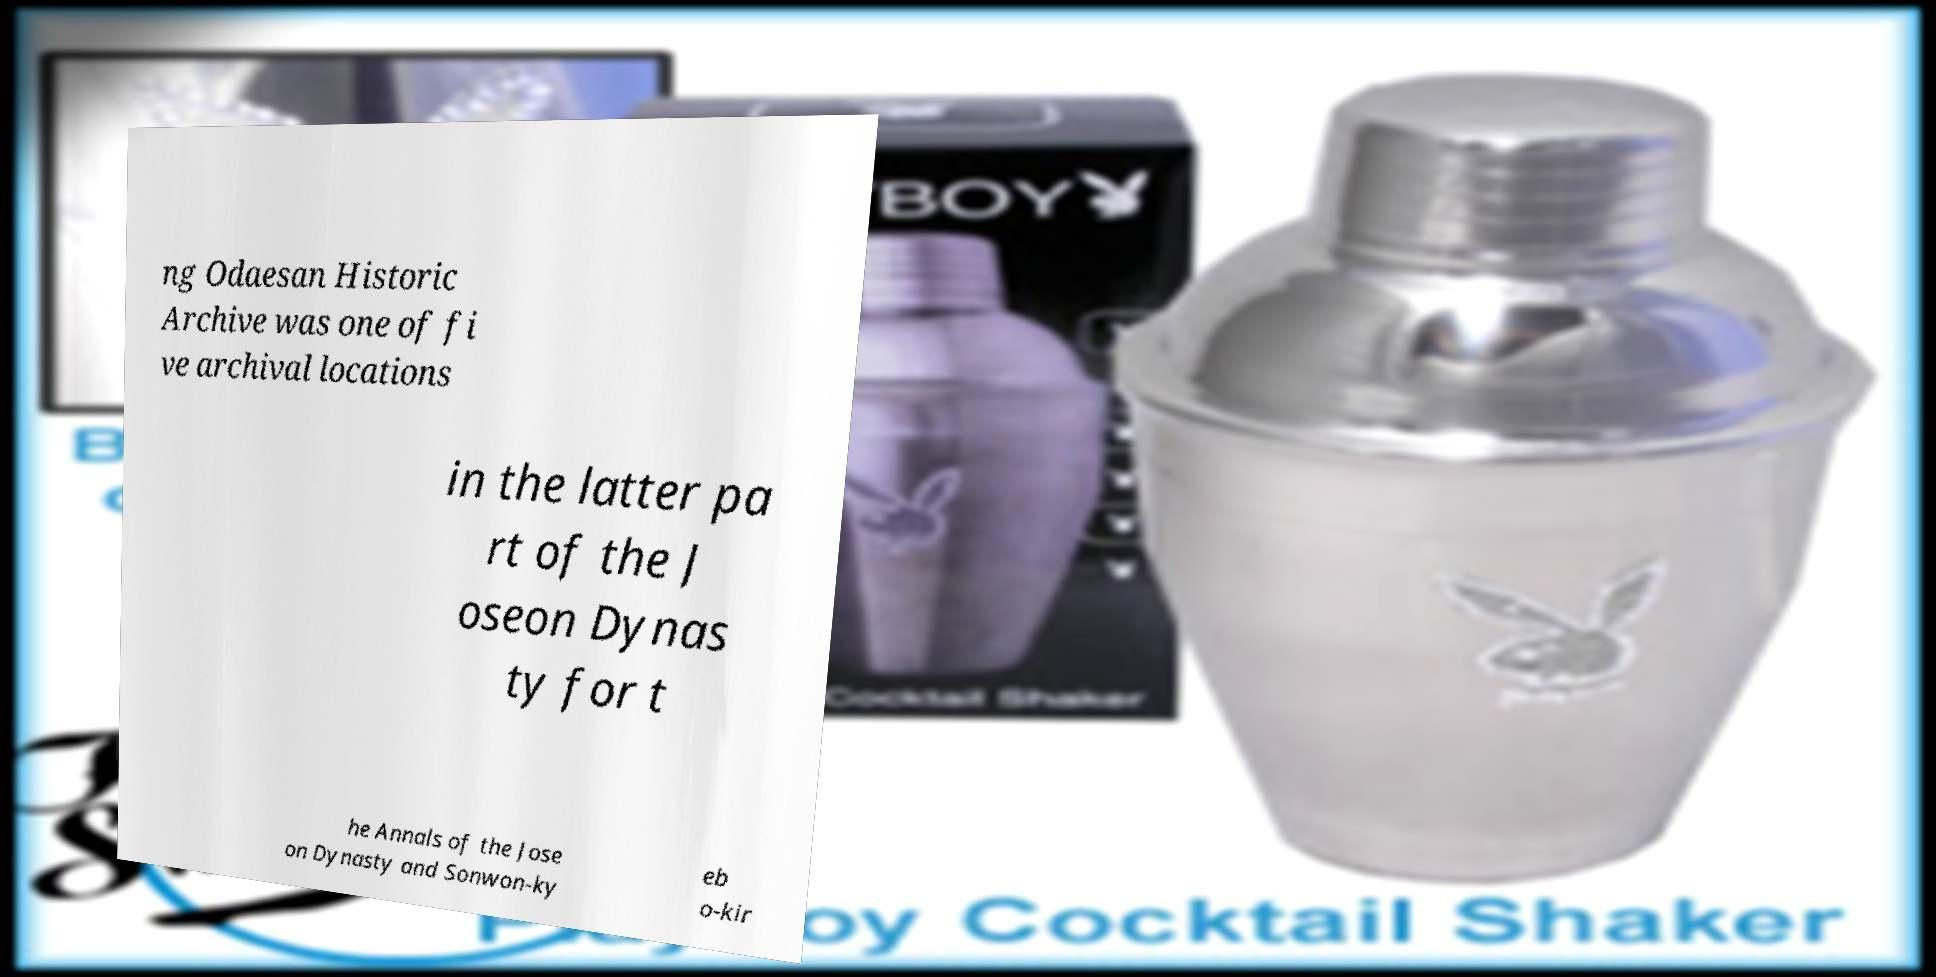Could you assist in decoding the text presented in this image and type it out clearly? ng Odaesan Historic Archive was one of fi ve archival locations in the latter pa rt of the J oseon Dynas ty for t he Annals of the Jose on Dynasty and Sonwon-ky eb o-kir 